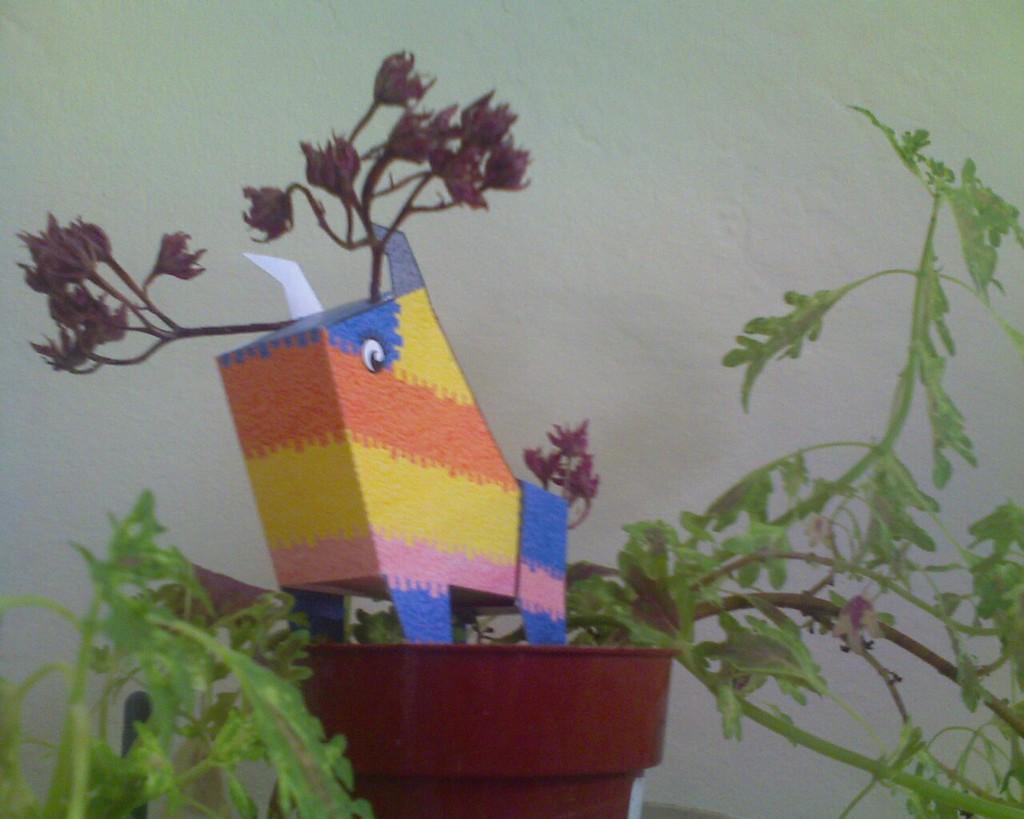Can you describe this image briefly? In the picture I can see a plant pot and some other objects. In the background I can see a white color wall. 